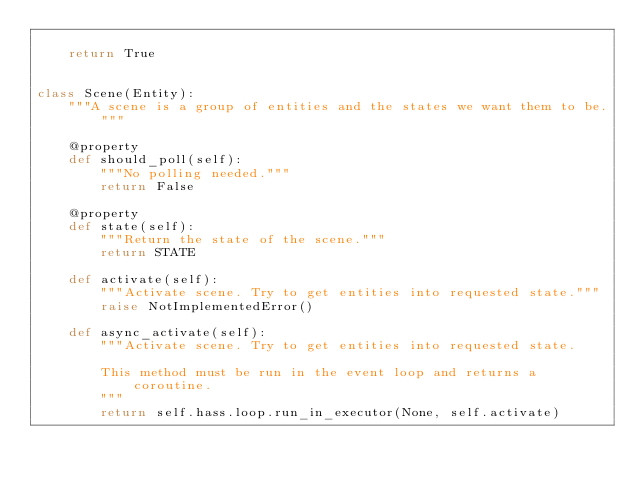Convert code to text. <code><loc_0><loc_0><loc_500><loc_500><_Python_>
    return True


class Scene(Entity):
    """A scene is a group of entities and the states we want them to be."""

    @property
    def should_poll(self):
        """No polling needed."""
        return False

    @property
    def state(self):
        """Return the state of the scene."""
        return STATE

    def activate(self):
        """Activate scene. Try to get entities into requested state."""
        raise NotImplementedError()

    def async_activate(self):
        """Activate scene. Try to get entities into requested state.

        This method must be run in the event loop and returns a coroutine.
        """
        return self.hass.loop.run_in_executor(None, self.activate)
</code> 